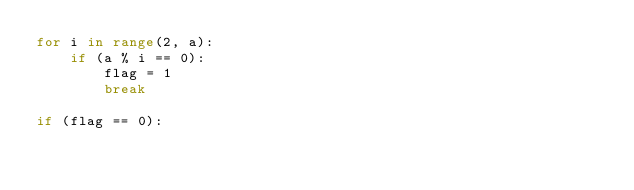Convert code to text. <code><loc_0><loc_0><loc_500><loc_500><_Python_>for i in range(2, a):
    if (a % i == 0):
        flag = 1
        break

if (flag == 0):</code> 